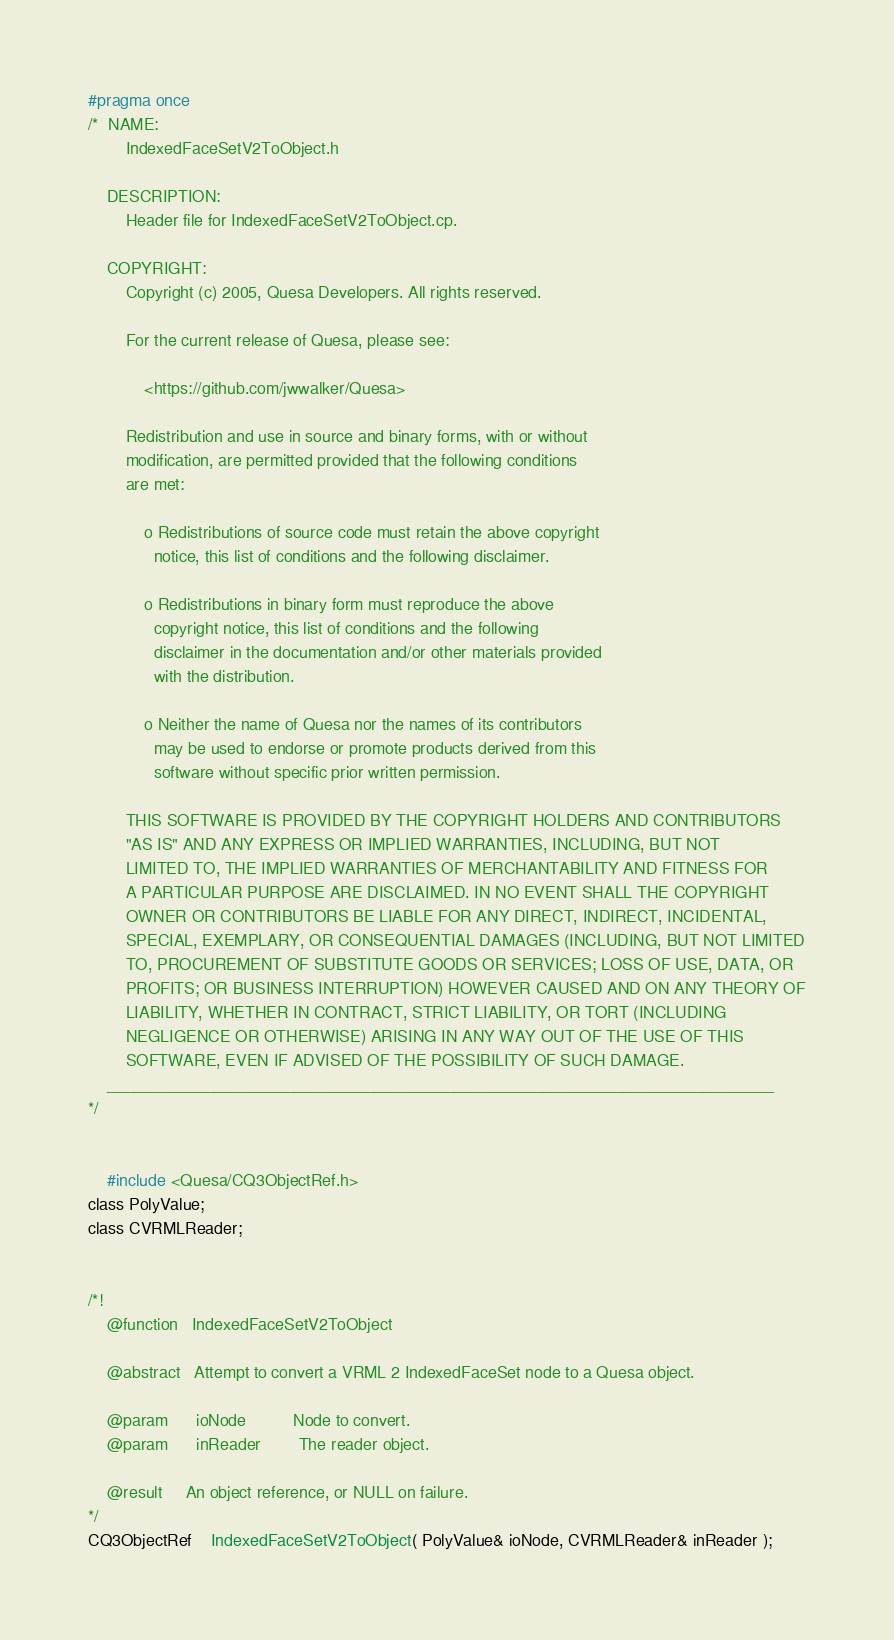Convert code to text. <code><loc_0><loc_0><loc_500><loc_500><_C_>#pragma once
/*  NAME:
        IndexedFaceSetV2ToObject.h

    DESCRIPTION:
        Header file for IndexedFaceSetV2ToObject.cp.

    COPYRIGHT:
        Copyright (c) 2005, Quesa Developers. All rights reserved.

        For the current release of Quesa, please see:

            <https://github.com/jwwalker/Quesa>
        
        Redistribution and use in source and binary forms, with or without
        modification, are permitted provided that the following conditions
        are met:
        
            o Redistributions of source code must retain the above copyright
              notice, this list of conditions and the following disclaimer.
        
            o Redistributions in binary form must reproduce the above
              copyright notice, this list of conditions and the following
              disclaimer in the documentation and/or other materials provided
              with the distribution.
        
            o Neither the name of Quesa nor the names of its contributors
              may be used to endorse or promote products derived from this
              software without specific prior written permission.
        
        THIS SOFTWARE IS PROVIDED BY THE COPYRIGHT HOLDERS AND CONTRIBUTORS
        "AS IS" AND ANY EXPRESS OR IMPLIED WARRANTIES, INCLUDING, BUT NOT
        LIMITED TO, THE IMPLIED WARRANTIES OF MERCHANTABILITY AND FITNESS FOR
        A PARTICULAR PURPOSE ARE DISCLAIMED. IN NO EVENT SHALL THE COPYRIGHT
        OWNER OR CONTRIBUTORS BE LIABLE FOR ANY DIRECT, INDIRECT, INCIDENTAL,
        SPECIAL, EXEMPLARY, OR CONSEQUENTIAL DAMAGES (INCLUDING, BUT NOT LIMITED
        TO, PROCUREMENT OF SUBSTITUTE GOODS OR SERVICES; LOSS OF USE, DATA, OR
        PROFITS; OR BUSINESS INTERRUPTION) HOWEVER CAUSED AND ON ANY THEORY OF
        LIABILITY, WHETHER IN CONTRACT, STRICT LIABILITY, OR TORT (INCLUDING
        NEGLIGENCE OR OTHERWISE) ARISING IN ANY WAY OUT OF THE USE OF THIS
        SOFTWARE, EVEN IF ADVISED OF THE POSSIBILITY OF SUCH DAMAGE.
    ___________________________________________________________________________
*/


	#include <Quesa/CQ3ObjectRef.h>
class PolyValue;
class CVRMLReader;


/*!
	@function	IndexedFaceSetV2ToObject
	
	@abstract	Attempt to convert a VRML 2 IndexedFaceSet node to a Quesa object.
	
	@param		ioNode			Node to convert.
	@param		inReader		The reader object.
	
	@result		An object reference, or NULL on failure.
*/
CQ3ObjectRef	IndexedFaceSetV2ToObject( PolyValue& ioNode, CVRMLReader& inReader );
</code> 